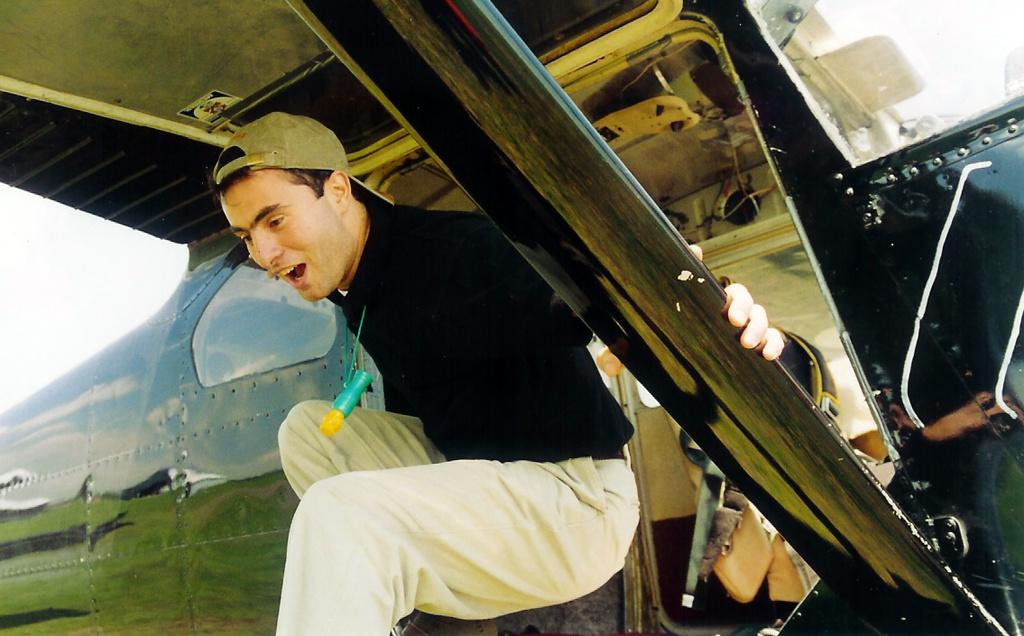What is the main subject of the picture? The main subject of the picture is an airplane. Can you describe the man in the picture? The man in the picture is wearing a cap and smiling. What type of surface is visible in the picture? There is grass in the picture. What else can be seen in the picture besides the airplane and the man? There are some objects in the picture. What is visible in the background of the picture? The sky is visible in the background of the picture. What type of bells can be heard ringing in the image? There are no bells present in the image, and therefore no sound can be heard. 